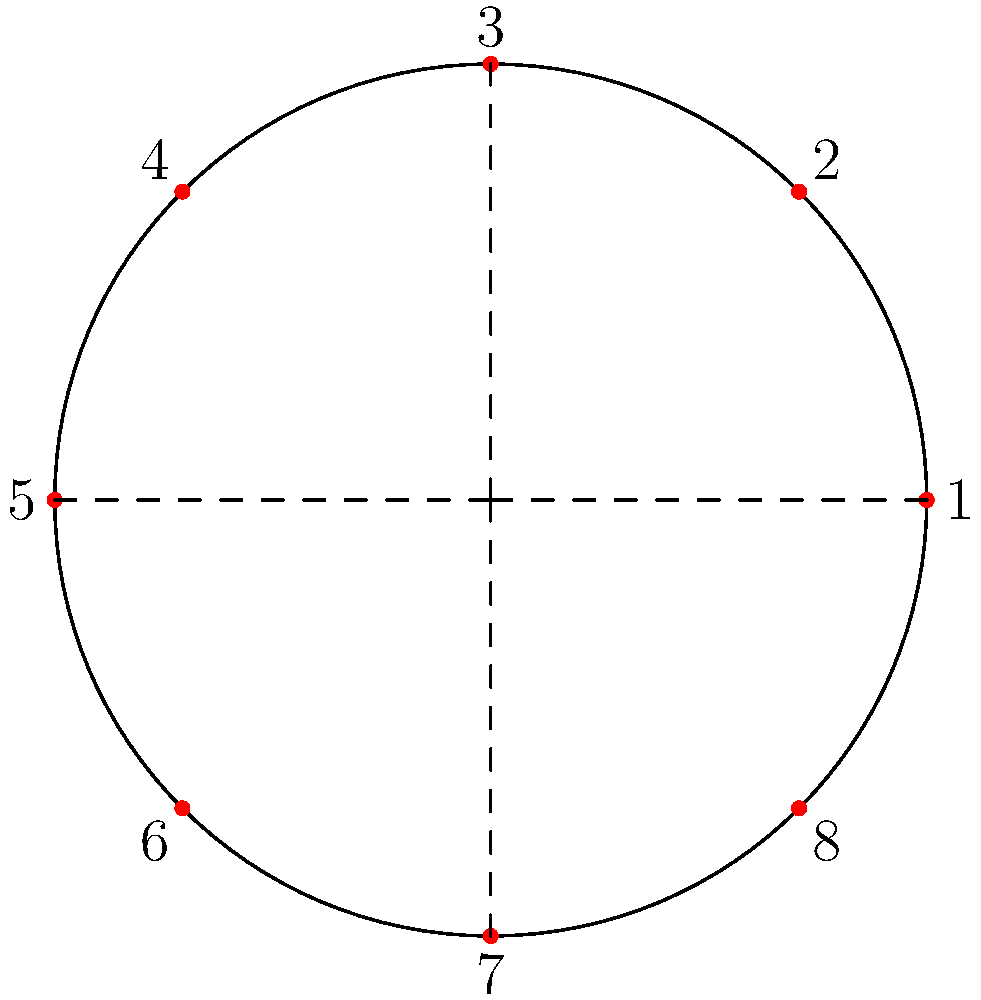In a circular salsa performance formation with 8 dancers, what is the optimal angle (in radians) between each dancer to ensure equal spacing? To find the optimal angle between dancers in a circular formation, we can follow these steps:

1. Recognize that a full circle contains 2π radians.

2. The dancers need to be equally spaced around the circle.

3. With 8 dancers, we need to divide the circle into 8 equal parts.

4. To calculate the angle between each dancer:
   $$ \text{Angle} = \frac{\text{Total radians in a circle}}{\text{Number of dancers}} $$
   $$ \text{Angle} = \frac{2\pi}{8} $$
   $$ \text{Angle} = \frac{\pi}{4} \text{ radians} $$

5. This angle ensures that the dancers are evenly distributed around the circle, creating a visually balanced formation for the salsa performance.

6. In the diagram, you can see that this arrangement places a dancer at each quarter of the circle (0, π/2, π, 3π/2) and halfway between these points, creating a symmetrical and aesthetically pleasing formation.
Answer: $\frac{\pi}{4}$ radians 